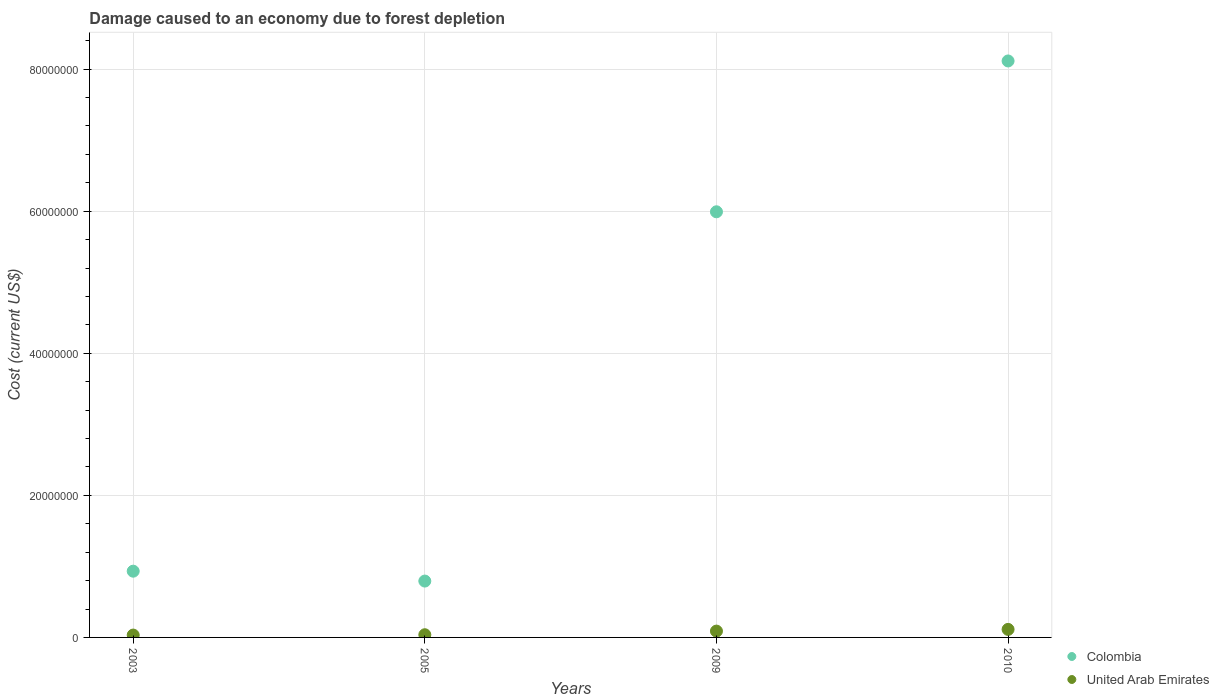How many different coloured dotlines are there?
Your answer should be compact. 2. What is the cost of damage caused due to forest depletion in Colombia in 2009?
Make the answer very short. 5.99e+07. Across all years, what is the maximum cost of damage caused due to forest depletion in Colombia?
Provide a succinct answer. 8.12e+07. Across all years, what is the minimum cost of damage caused due to forest depletion in Colombia?
Provide a short and direct response. 7.93e+06. In which year was the cost of damage caused due to forest depletion in United Arab Emirates maximum?
Offer a very short reply. 2010. In which year was the cost of damage caused due to forest depletion in United Arab Emirates minimum?
Offer a very short reply. 2003. What is the total cost of damage caused due to forest depletion in Colombia in the graph?
Provide a succinct answer. 1.58e+08. What is the difference between the cost of damage caused due to forest depletion in United Arab Emirates in 2003 and that in 2005?
Make the answer very short. -4.60e+04. What is the difference between the cost of damage caused due to forest depletion in Colombia in 2003 and the cost of damage caused due to forest depletion in United Arab Emirates in 2010?
Your answer should be compact. 8.20e+06. What is the average cost of damage caused due to forest depletion in United Arab Emirates per year?
Your answer should be compact. 6.83e+05. In the year 2003, what is the difference between the cost of damage caused due to forest depletion in United Arab Emirates and cost of damage caused due to forest depletion in Colombia?
Ensure brevity in your answer.  -8.99e+06. What is the ratio of the cost of damage caused due to forest depletion in Colombia in 2005 to that in 2010?
Provide a succinct answer. 0.1. What is the difference between the highest and the second highest cost of damage caused due to forest depletion in United Arab Emirates?
Offer a terse response. 2.40e+05. What is the difference between the highest and the lowest cost of damage caused due to forest depletion in United Arab Emirates?
Offer a terse response. 7.99e+05. In how many years, is the cost of damage caused due to forest depletion in Colombia greater than the average cost of damage caused due to forest depletion in Colombia taken over all years?
Your answer should be very brief. 2. How many dotlines are there?
Your response must be concise. 2. What is the difference between two consecutive major ticks on the Y-axis?
Keep it short and to the point. 2.00e+07. Are the values on the major ticks of Y-axis written in scientific E-notation?
Make the answer very short. No. Does the graph contain any zero values?
Provide a short and direct response. No. Does the graph contain grids?
Provide a short and direct response. Yes. How are the legend labels stacked?
Offer a very short reply. Vertical. What is the title of the graph?
Give a very brief answer. Damage caused to an economy due to forest depletion. What is the label or title of the X-axis?
Your answer should be compact. Years. What is the label or title of the Y-axis?
Offer a very short reply. Cost (current US$). What is the Cost (current US$) in Colombia in 2003?
Your answer should be compact. 9.33e+06. What is the Cost (current US$) in United Arab Emirates in 2003?
Your response must be concise. 3.32e+05. What is the Cost (current US$) of Colombia in 2005?
Make the answer very short. 7.93e+06. What is the Cost (current US$) of United Arab Emirates in 2005?
Provide a succinct answer. 3.78e+05. What is the Cost (current US$) of Colombia in 2009?
Ensure brevity in your answer.  5.99e+07. What is the Cost (current US$) in United Arab Emirates in 2009?
Your answer should be very brief. 8.90e+05. What is the Cost (current US$) of Colombia in 2010?
Your response must be concise. 8.12e+07. What is the Cost (current US$) of United Arab Emirates in 2010?
Ensure brevity in your answer.  1.13e+06. Across all years, what is the maximum Cost (current US$) in Colombia?
Provide a succinct answer. 8.12e+07. Across all years, what is the maximum Cost (current US$) in United Arab Emirates?
Provide a short and direct response. 1.13e+06. Across all years, what is the minimum Cost (current US$) of Colombia?
Make the answer very short. 7.93e+06. Across all years, what is the minimum Cost (current US$) in United Arab Emirates?
Your answer should be very brief. 3.32e+05. What is the total Cost (current US$) of Colombia in the graph?
Provide a short and direct response. 1.58e+08. What is the total Cost (current US$) of United Arab Emirates in the graph?
Provide a short and direct response. 2.73e+06. What is the difference between the Cost (current US$) in Colombia in 2003 and that in 2005?
Provide a succinct answer. 1.39e+06. What is the difference between the Cost (current US$) of United Arab Emirates in 2003 and that in 2005?
Your response must be concise. -4.60e+04. What is the difference between the Cost (current US$) of Colombia in 2003 and that in 2009?
Give a very brief answer. -5.06e+07. What is the difference between the Cost (current US$) in United Arab Emirates in 2003 and that in 2009?
Offer a terse response. -5.58e+05. What is the difference between the Cost (current US$) of Colombia in 2003 and that in 2010?
Provide a short and direct response. -7.18e+07. What is the difference between the Cost (current US$) in United Arab Emirates in 2003 and that in 2010?
Offer a very short reply. -7.99e+05. What is the difference between the Cost (current US$) in Colombia in 2005 and that in 2009?
Provide a succinct answer. -5.20e+07. What is the difference between the Cost (current US$) in United Arab Emirates in 2005 and that in 2009?
Ensure brevity in your answer.  -5.12e+05. What is the difference between the Cost (current US$) of Colombia in 2005 and that in 2010?
Offer a terse response. -7.32e+07. What is the difference between the Cost (current US$) of United Arab Emirates in 2005 and that in 2010?
Make the answer very short. -7.53e+05. What is the difference between the Cost (current US$) in Colombia in 2009 and that in 2010?
Give a very brief answer. -2.12e+07. What is the difference between the Cost (current US$) of United Arab Emirates in 2009 and that in 2010?
Your answer should be compact. -2.40e+05. What is the difference between the Cost (current US$) in Colombia in 2003 and the Cost (current US$) in United Arab Emirates in 2005?
Offer a terse response. 8.95e+06. What is the difference between the Cost (current US$) of Colombia in 2003 and the Cost (current US$) of United Arab Emirates in 2009?
Ensure brevity in your answer.  8.44e+06. What is the difference between the Cost (current US$) in Colombia in 2003 and the Cost (current US$) in United Arab Emirates in 2010?
Make the answer very short. 8.20e+06. What is the difference between the Cost (current US$) in Colombia in 2005 and the Cost (current US$) in United Arab Emirates in 2009?
Provide a succinct answer. 7.04e+06. What is the difference between the Cost (current US$) in Colombia in 2005 and the Cost (current US$) in United Arab Emirates in 2010?
Keep it short and to the point. 6.80e+06. What is the difference between the Cost (current US$) of Colombia in 2009 and the Cost (current US$) of United Arab Emirates in 2010?
Make the answer very short. 5.88e+07. What is the average Cost (current US$) of Colombia per year?
Provide a short and direct response. 3.96e+07. What is the average Cost (current US$) in United Arab Emirates per year?
Give a very brief answer. 6.83e+05. In the year 2003, what is the difference between the Cost (current US$) in Colombia and Cost (current US$) in United Arab Emirates?
Ensure brevity in your answer.  8.99e+06. In the year 2005, what is the difference between the Cost (current US$) of Colombia and Cost (current US$) of United Arab Emirates?
Make the answer very short. 7.56e+06. In the year 2009, what is the difference between the Cost (current US$) of Colombia and Cost (current US$) of United Arab Emirates?
Keep it short and to the point. 5.90e+07. In the year 2010, what is the difference between the Cost (current US$) of Colombia and Cost (current US$) of United Arab Emirates?
Keep it short and to the point. 8.00e+07. What is the ratio of the Cost (current US$) in Colombia in 2003 to that in 2005?
Your response must be concise. 1.18. What is the ratio of the Cost (current US$) in United Arab Emirates in 2003 to that in 2005?
Your response must be concise. 0.88. What is the ratio of the Cost (current US$) in Colombia in 2003 to that in 2009?
Make the answer very short. 0.16. What is the ratio of the Cost (current US$) in United Arab Emirates in 2003 to that in 2009?
Offer a very short reply. 0.37. What is the ratio of the Cost (current US$) in Colombia in 2003 to that in 2010?
Provide a succinct answer. 0.11. What is the ratio of the Cost (current US$) in United Arab Emirates in 2003 to that in 2010?
Offer a terse response. 0.29. What is the ratio of the Cost (current US$) in Colombia in 2005 to that in 2009?
Your answer should be compact. 0.13. What is the ratio of the Cost (current US$) of United Arab Emirates in 2005 to that in 2009?
Keep it short and to the point. 0.42. What is the ratio of the Cost (current US$) of Colombia in 2005 to that in 2010?
Give a very brief answer. 0.1. What is the ratio of the Cost (current US$) of United Arab Emirates in 2005 to that in 2010?
Your response must be concise. 0.33. What is the ratio of the Cost (current US$) of Colombia in 2009 to that in 2010?
Your answer should be compact. 0.74. What is the ratio of the Cost (current US$) in United Arab Emirates in 2009 to that in 2010?
Your answer should be compact. 0.79. What is the difference between the highest and the second highest Cost (current US$) in Colombia?
Offer a very short reply. 2.12e+07. What is the difference between the highest and the second highest Cost (current US$) of United Arab Emirates?
Provide a short and direct response. 2.40e+05. What is the difference between the highest and the lowest Cost (current US$) of Colombia?
Offer a very short reply. 7.32e+07. What is the difference between the highest and the lowest Cost (current US$) of United Arab Emirates?
Your answer should be very brief. 7.99e+05. 